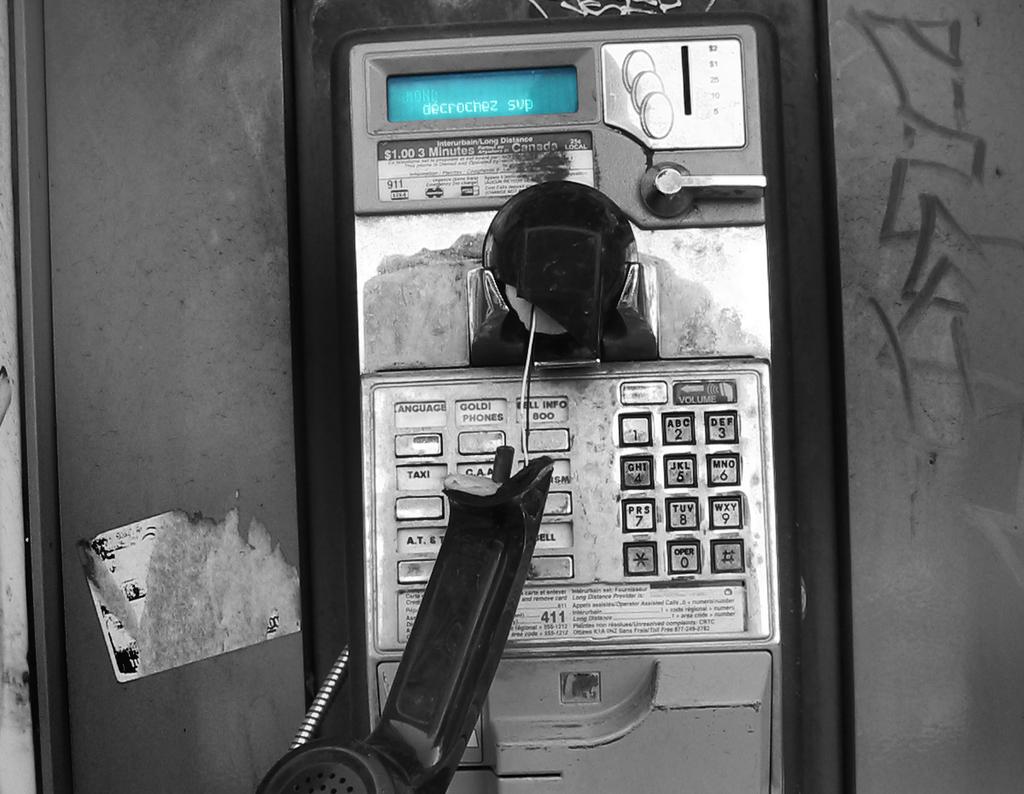What button is seen between the star and the pound sign?
Your response must be concise. 0. 